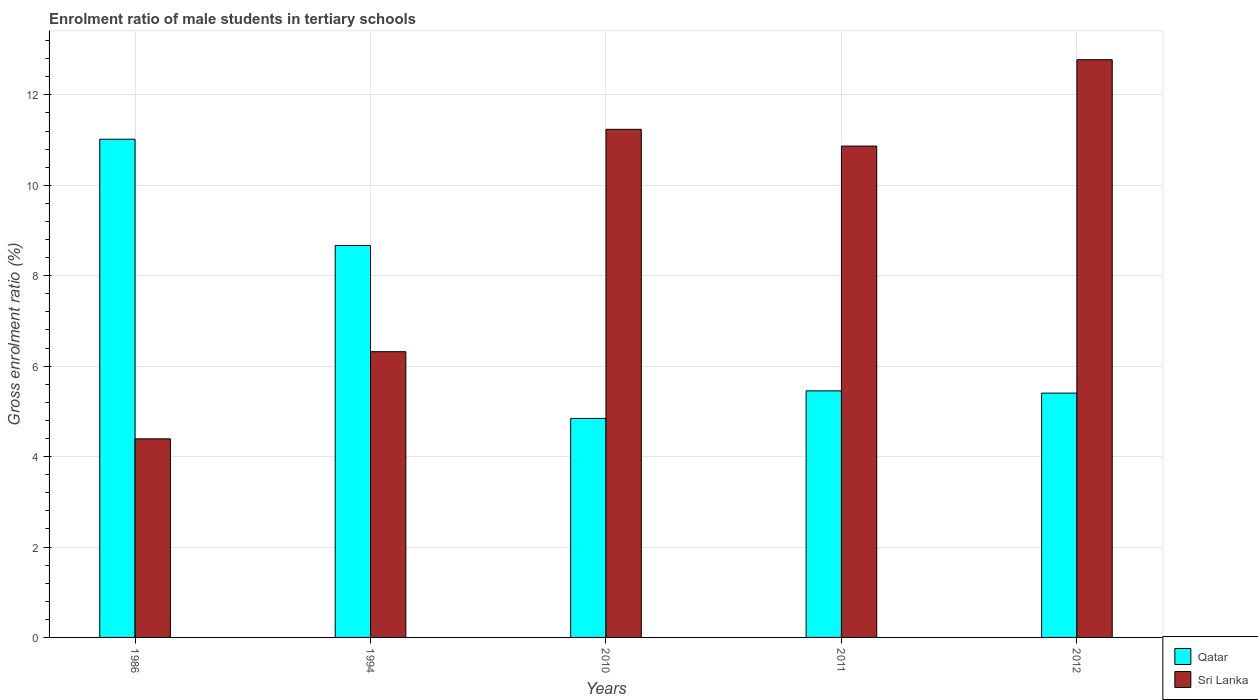How many groups of bars are there?
Your answer should be compact. 5. Are the number of bars on each tick of the X-axis equal?
Your response must be concise. Yes. How many bars are there on the 4th tick from the right?
Ensure brevity in your answer.  2. What is the label of the 3rd group of bars from the left?
Your response must be concise. 2010. What is the enrolment ratio of male students in tertiary schools in Qatar in 1986?
Your answer should be compact. 11.02. Across all years, what is the maximum enrolment ratio of male students in tertiary schools in Sri Lanka?
Give a very brief answer. 12.78. Across all years, what is the minimum enrolment ratio of male students in tertiary schools in Qatar?
Offer a very short reply. 4.84. What is the total enrolment ratio of male students in tertiary schools in Qatar in the graph?
Make the answer very short. 35.39. What is the difference between the enrolment ratio of male students in tertiary schools in Qatar in 2011 and that in 2012?
Offer a terse response. 0.05. What is the difference between the enrolment ratio of male students in tertiary schools in Sri Lanka in 2010 and the enrolment ratio of male students in tertiary schools in Qatar in 1994?
Offer a very short reply. 2.57. What is the average enrolment ratio of male students in tertiary schools in Qatar per year?
Give a very brief answer. 7.08. In the year 2011, what is the difference between the enrolment ratio of male students in tertiary schools in Qatar and enrolment ratio of male students in tertiary schools in Sri Lanka?
Provide a succinct answer. -5.41. In how many years, is the enrolment ratio of male students in tertiary schools in Sri Lanka greater than 5.2 %?
Give a very brief answer. 4. What is the ratio of the enrolment ratio of male students in tertiary schools in Sri Lanka in 1986 to that in 2011?
Your answer should be compact. 0.4. Is the enrolment ratio of male students in tertiary schools in Qatar in 1986 less than that in 2012?
Ensure brevity in your answer.  No. What is the difference between the highest and the second highest enrolment ratio of male students in tertiary schools in Sri Lanka?
Make the answer very short. 1.54. What is the difference between the highest and the lowest enrolment ratio of male students in tertiary schools in Sri Lanka?
Offer a terse response. 8.39. In how many years, is the enrolment ratio of male students in tertiary schools in Qatar greater than the average enrolment ratio of male students in tertiary schools in Qatar taken over all years?
Ensure brevity in your answer.  2. Is the sum of the enrolment ratio of male students in tertiary schools in Sri Lanka in 1986 and 2011 greater than the maximum enrolment ratio of male students in tertiary schools in Qatar across all years?
Keep it short and to the point. Yes. What does the 1st bar from the left in 2010 represents?
Provide a succinct answer. Qatar. What does the 1st bar from the right in 2011 represents?
Make the answer very short. Sri Lanka. What is the difference between two consecutive major ticks on the Y-axis?
Provide a succinct answer. 2. Where does the legend appear in the graph?
Give a very brief answer. Bottom right. What is the title of the graph?
Offer a very short reply. Enrolment ratio of male students in tertiary schools. Does "Grenada" appear as one of the legend labels in the graph?
Provide a short and direct response. No. What is the Gross enrolment ratio (%) in Qatar in 1986?
Your response must be concise. 11.02. What is the Gross enrolment ratio (%) of Sri Lanka in 1986?
Provide a short and direct response. 4.39. What is the Gross enrolment ratio (%) in Qatar in 1994?
Provide a short and direct response. 8.67. What is the Gross enrolment ratio (%) of Sri Lanka in 1994?
Offer a terse response. 6.32. What is the Gross enrolment ratio (%) of Qatar in 2010?
Offer a very short reply. 4.84. What is the Gross enrolment ratio (%) of Sri Lanka in 2010?
Your response must be concise. 11.24. What is the Gross enrolment ratio (%) in Qatar in 2011?
Your answer should be very brief. 5.45. What is the Gross enrolment ratio (%) of Sri Lanka in 2011?
Your response must be concise. 10.87. What is the Gross enrolment ratio (%) of Qatar in 2012?
Provide a succinct answer. 5.4. What is the Gross enrolment ratio (%) of Sri Lanka in 2012?
Your answer should be very brief. 12.78. Across all years, what is the maximum Gross enrolment ratio (%) of Qatar?
Ensure brevity in your answer.  11.02. Across all years, what is the maximum Gross enrolment ratio (%) in Sri Lanka?
Your answer should be very brief. 12.78. Across all years, what is the minimum Gross enrolment ratio (%) of Qatar?
Provide a short and direct response. 4.84. Across all years, what is the minimum Gross enrolment ratio (%) of Sri Lanka?
Make the answer very short. 4.39. What is the total Gross enrolment ratio (%) of Qatar in the graph?
Give a very brief answer. 35.39. What is the total Gross enrolment ratio (%) in Sri Lanka in the graph?
Your answer should be compact. 45.6. What is the difference between the Gross enrolment ratio (%) in Qatar in 1986 and that in 1994?
Keep it short and to the point. 2.35. What is the difference between the Gross enrolment ratio (%) of Sri Lanka in 1986 and that in 1994?
Keep it short and to the point. -1.93. What is the difference between the Gross enrolment ratio (%) of Qatar in 1986 and that in 2010?
Make the answer very short. 6.18. What is the difference between the Gross enrolment ratio (%) in Sri Lanka in 1986 and that in 2010?
Your answer should be compact. -6.85. What is the difference between the Gross enrolment ratio (%) of Qatar in 1986 and that in 2011?
Offer a terse response. 5.57. What is the difference between the Gross enrolment ratio (%) in Sri Lanka in 1986 and that in 2011?
Offer a terse response. -6.48. What is the difference between the Gross enrolment ratio (%) of Qatar in 1986 and that in 2012?
Provide a short and direct response. 5.62. What is the difference between the Gross enrolment ratio (%) in Sri Lanka in 1986 and that in 2012?
Offer a very short reply. -8.39. What is the difference between the Gross enrolment ratio (%) in Qatar in 1994 and that in 2010?
Provide a succinct answer. 3.83. What is the difference between the Gross enrolment ratio (%) in Sri Lanka in 1994 and that in 2010?
Keep it short and to the point. -4.92. What is the difference between the Gross enrolment ratio (%) of Qatar in 1994 and that in 2011?
Ensure brevity in your answer.  3.22. What is the difference between the Gross enrolment ratio (%) of Sri Lanka in 1994 and that in 2011?
Make the answer very short. -4.55. What is the difference between the Gross enrolment ratio (%) of Qatar in 1994 and that in 2012?
Offer a terse response. 3.27. What is the difference between the Gross enrolment ratio (%) in Sri Lanka in 1994 and that in 2012?
Your answer should be compact. -6.46. What is the difference between the Gross enrolment ratio (%) of Qatar in 2010 and that in 2011?
Offer a terse response. -0.61. What is the difference between the Gross enrolment ratio (%) of Sri Lanka in 2010 and that in 2011?
Your response must be concise. 0.37. What is the difference between the Gross enrolment ratio (%) of Qatar in 2010 and that in 2012?
Offer a very short reply. -0.56. What is the difference between the Gross enrolment ratio (%) in Sri Lanka in 2010 and that in 2012?
Keep it short and to the point. -1.54. What is the difference between the Gross enrolment ratio (%) in Qatar in 2011 and that in 2012?
Make the answer very short. 0.05. What is the difference between the Gross enrolment ratio (%) in Sri Lanka in 2011 and that in 2012?
Offer a very short reply. -1.91. What is the difference between the Gross enrolment ratio (%) of Qatar in 1986 and the Gross enrolment ratio (%) of Sri Lanka in 1994?
Make the answer very short. 4.7. What is the difference between the Gross enrolment ratio (%) in Qatar in 1986 and the Gross enrolment ratio (%) in Sri Lanka in 2010?
Offer a very short reply. -0.22. What is the difference between the Gross enrolment ratio (%) of Qatar in 1986 and the Gross enrolment ratio (%) of Sri Lanka in 2011?
Make the answer very short. 0.15. What is the difference between the Gross enrolment ratio (%) of Qatar in 1986 and the Gross enrolment ratio (%) of Sri Lanka in 2012?
Ensure brevity in your answer.  -1.76. What is the difference between the Gross enrolment ratio (%) in Qatar in 1994 and the Gross enrolment ratio (%) in Sri Lanka in 2010?
Keep it short and to the point. -2.57. What is the difference between the Gross enrolment ratio (%) of Qatar in 1994 and the Gross enrolment ratio (%) of Sri Lanka in 2011?
Your answer should be very brief. -2.2. What is the difference between the Gross enrolment ratio (%) in Qatar in 1994 and the Gross enrolment ratio (%) in Sri Lanka in 2012?
Your response must be concise. -4.11. What is the difference between the Gross enrolment ratio (%) of Qatar in 2010 and the Gross enrolment ratio (%) of Sri Lanka in 2011?
Provide a succinct answer. -6.02. What is the difference between the Gross enrolment ratio (%) of Qatar in 2010 and the Gross enrolment ratio (%) of Sri Lanka in 2012?
Give a very brief answer. -7.93. What is the difference between the Gross enrolment ratio (%) in Qatar in 2011 and the Gross enrolment ratio (%) in Sri Lanka in 2012?
Your answer should be very brief. -7.32. What is the average Gross enrolment ratio (%) of Qatar per year?
Your answer should be very brief. 7.08. What is the average Gross enrolment ratio (%) of Sri Lanka per year?
Provide a succinct answer. 9.12. In the year 1986, what is the difference between the Gross enrolment ratio (%) of Qatar and Gross enrolment ratio (%) of Sri Lanka?
Provide a short and direct response. 6.63. In the year 1994, what is the difference between the Gross enrolment ratio (%) of Qatar and Gross enrolment ratio (%) of Sri Lanka?
Offer a terse response. 2.35. In the year 2010, what is the difference between the Gross enrolment ratio (%) of Qatar and Gross enrolment ratio (%) of Sri Lanka?
Your answer should be very brief. -6.39. In the year 2011, what is the difference between the Gross enrolment ratio (%) in Qatar and Gross enrolment ratio (%) in Sri Lanka?
Give a very brief answer. -5.41. In the year 2012, what is the difference between the Gross enrolment ratio (%) in Qatar and Gross enrolment ratio (%) in Sri Lanka?
Keep it short and to the point. -7.37. What is the ratio of the Gross enrolment ratio (%) of Qatar in 1986 to that in 1994?
Provide a succinct answer. 1.27. What is the ratio of the Gross enrolment ratio (%) in Sri Lanka in 1986 to that in 1994?
Your response must be concise. 0.69. What is the ratio of the Gross enrolment ratio (%) in Qatar in 1986 to that in 2010?
Your answer should be compact. 2.27. What is the ratio of the Gross enrolment ratio (%) of Sri Lanka in 1986 to that in 2010?
Offer a terse response. 0.39. What is the ratio of the Gross enrolment ratio (%) of Qatar in 1986 to that in 2011?
Your answer should be very brief. 2.02. What is the ratio of the Gross enrolment ratio (%) of Sri Lanka in 1986 to that in 2011?
Give a very brief answer. 0.4. What is the ratio of the Gross enrolment ratio (%) in Qatar in 1986 to that in 2012?
Offer a terse response. 2.04. What is the ratio of the Gross enrolment ratio (%) of Sri Lanka in 1986 to that in 2012?
Keep it short and to the point. 0.34. What is the ratio of the Gross enrolment ratio (%) in Qatar in 1994 to that in 2010?
Offer a terse response. 1.79. What is the ratio of the Gross enrolment ratio (%) of Sri Lanka in 1994 to that in 2010?
Keep it short and to the point. 0.56. What is the ratio of the Gross enrolment ratio (%) in Qatar in 1994 to that in 2011?
Offer a terse response. 1.59. What is the ratio of the Gross enrolment ratio (%) of Sri Lanka in 1994 to that in 2011?
Offer a very short reply. 0.58. What is the ratio of the Gross enrolment ratio (%) of Qatar in 1994 to that in 2012?
Provide a short and direct response. 1.6. What is the ratio of the Gross enrolment ratio (%) of Sri Lanka in 1994 to that in 2012?
Provide a succinct answer. 0.49. What is the ratio of the Gross enrolment ratio (%) in Qatar in 2010 to that in 2011?
Your answer should be compact. 0.89. What is the ratio of the Gross enrolment ratio (%) in Sri Lanka in 2010 to that in 2011?
Keep it short and to the point. 1.03. What is the ratio of the Gross enrolment ratio (%) of Qatar in 2010 to that in 2012?
Keep it short and to the point. 0.9. What is the ratio of the Gross enrolment ratio (%) of Sri Lanka in 2010 to that in 2012?
Give a very brief answer. 0.88. What is the ratio of the Gross enrolment ratio (%) in Qatar in 2011 to that in 2012?
Give a very brief answer. 1.01. What is the ratio of the Gross enrolment ratio (%) in Sri Lanka in 2011 to that in 2012?
Your answer should be compact. 0.85. What is the difference between the highest and the second highest Gross enrolment ratio (%) of Qatar?
Offer a very short reply. 2.35. What is the difference between the highest and the second highest Gross enrolment ratio (%) in Sri Lanka?
Make the answer very short. 1.54. What is the difference between the highest and the lowest Gross enrolment ratio (%) in Qatar?
Make the answer very short. 6.18. What is the difference between the highest and the lowest Gross enrolment ratio (%) in Sri Lanka?
Ensure brevity in your answer.  8.39. 